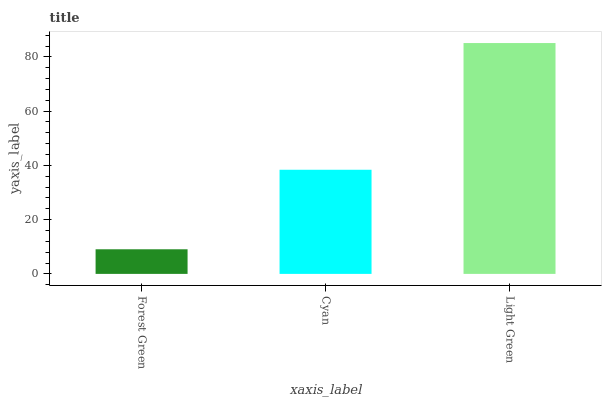Is Forest Green the minimum?
Answer yes or no. Yes. Is Light Green the maximum?
Answer yes or no. Yes. Is Cyan the minimum?
Answer yes or no. No. Is Cyan the maximum?
Answer yes or no. No. Is Cyan greater than Forest Green?
Answer yes or no. Yes. Is Forest Green less than Cyan?
Answer yes or no. Yes. Is Forest Green greater than Cyan?
Answer yes or no. No. Is Cyan less than Forest Green?
Answer yes or no. No. Is Cyan the high median?
Answer yes or no. Yes. Is Cyan the low median?
Answer yes or no. Yes. Is Forest Green the high median?
Answer yes or no. No. Is Light Green the low median?
Answer yes or no. No. 